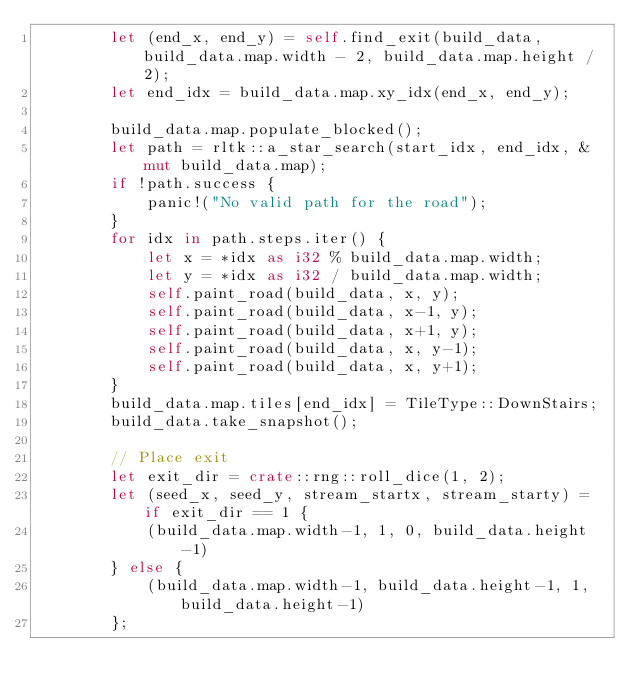<code> <loc_0><loc_0><loc_500><loc_500><_Rust_>        let (end_x, end_y) = self.find_exit(build_data, build_data.map.width - 2, build_data.map.height / 2);
        let end_idx = build_data.map.xy_idx(end_x, end_y);

        build_data.map.populate_blocked();
        let path = rltk::a_star_search(start_idx, end_idx, &mut build_data.map);
        if !path.success {
            panic!("No valid path for the road");
        }
        for idx in path.steps.iter() {
            let x = *idx as i32 % build_data.map.width;
            let y = *idx as i32 / build_data.map.width;
            self.paint_road(build_data, x, y);
            self.paint_road(build_data, x-1, y);
            self.paint_road(build_data, x+1, y);
            self.paint_road(build_data, x, y-1);
            self.paint_road(build_data, x, y+1);
        }
        build_data.map.tiles[end_idx] = TileType::DownStairs;
        build_data.take_snapshot();

        // Place exit
        let exit_dir = crate::rng::roll_dice(1, 2);
        let (seed_x, seed_y, stream_startx, stream_starty) = if exit_dir == 1 {
            (build_data.map.width-1, 1, 0, build_data.height-1)
        } else {
            (build_data.map.width-1, build_data.height-1, 1, build_data.height-1)
        };
</code> 